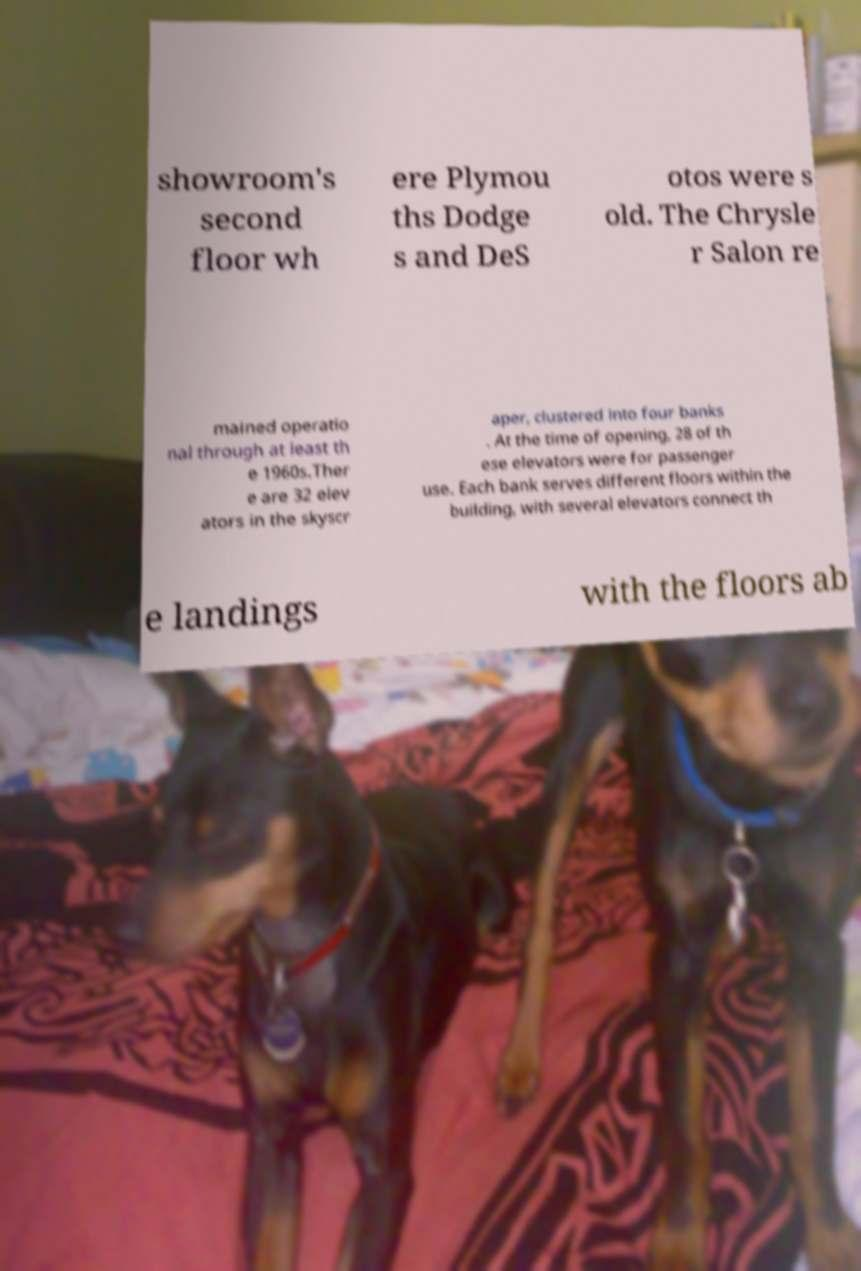There's text embedded in this image that I need extracted. Can you transcribe it verbatim? showroom's second floor wh ere Plymou ths Dodge s and DeS otos were s old. The Chrysle r Salon re mained operatio nal through at least th e 1960s.Ther e are 32 elev ators in the skyscr aper, clustered into four banks . At the time of opening, 28 of th ese elevators were for passenger use. Each bank serves different floors within the building, with several elevators connect th e landings with the floors ab 